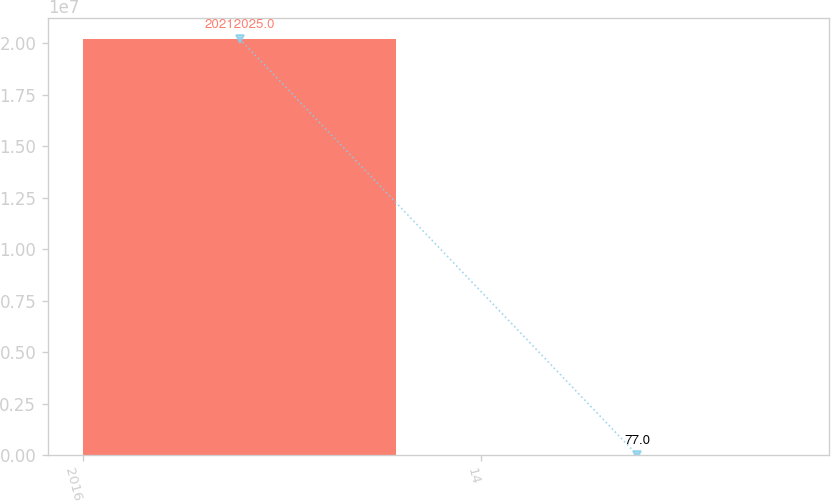Convert chart to OTSL. <chart><loc_0><loc_0><loc_500><loc_500><bar_chart><fcel>2016<fcel>14<nl><fcel>2.0212e+07<fcel>77<nl></chart> 